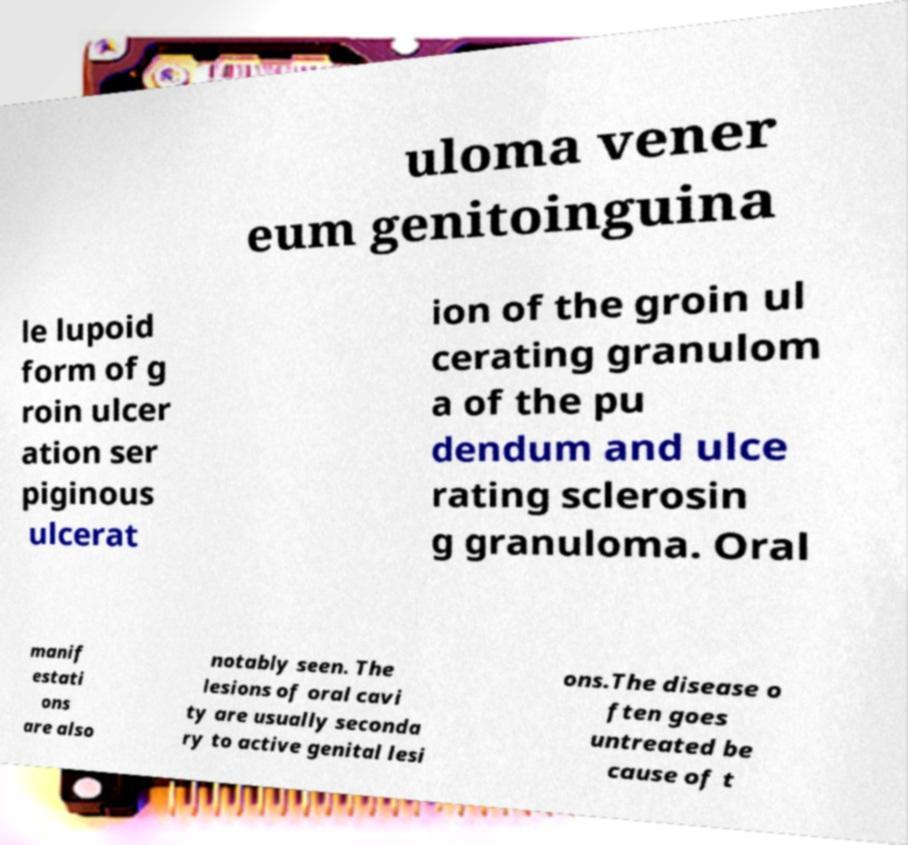There's text embedded in this image that I need extracted. Can you transcribe it verbatim? uloma vener eum genitoinguina le lupoid form of g roin ulcer ation ser piginous ulcerat ion of the groin ul cerating granulom a of the pu dendum and ulce rating sclerosin g granuloma. Oral manif estati ons are also notably seen. The lesions of oral cavi ty are usually seconda ry to active genital lesi ons.The disease o ften goes untreated be cause of t 